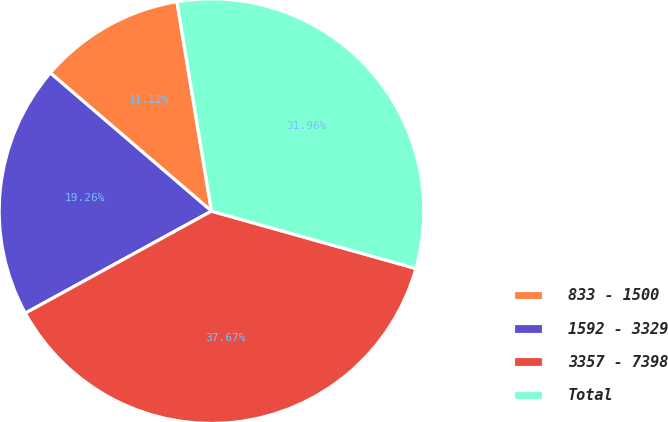Convert chart. <chart><loc_0><loc_0><loc_500><loc_500><pie_chart><fcel>833 - 1500<fcel>1592 - 3329<fcel>3357 - 7398<fcel>Total<nl><fcel>11.12%<fcel>19.26%<fcel>37.67%<fcel>31.96%<nl></chart> 